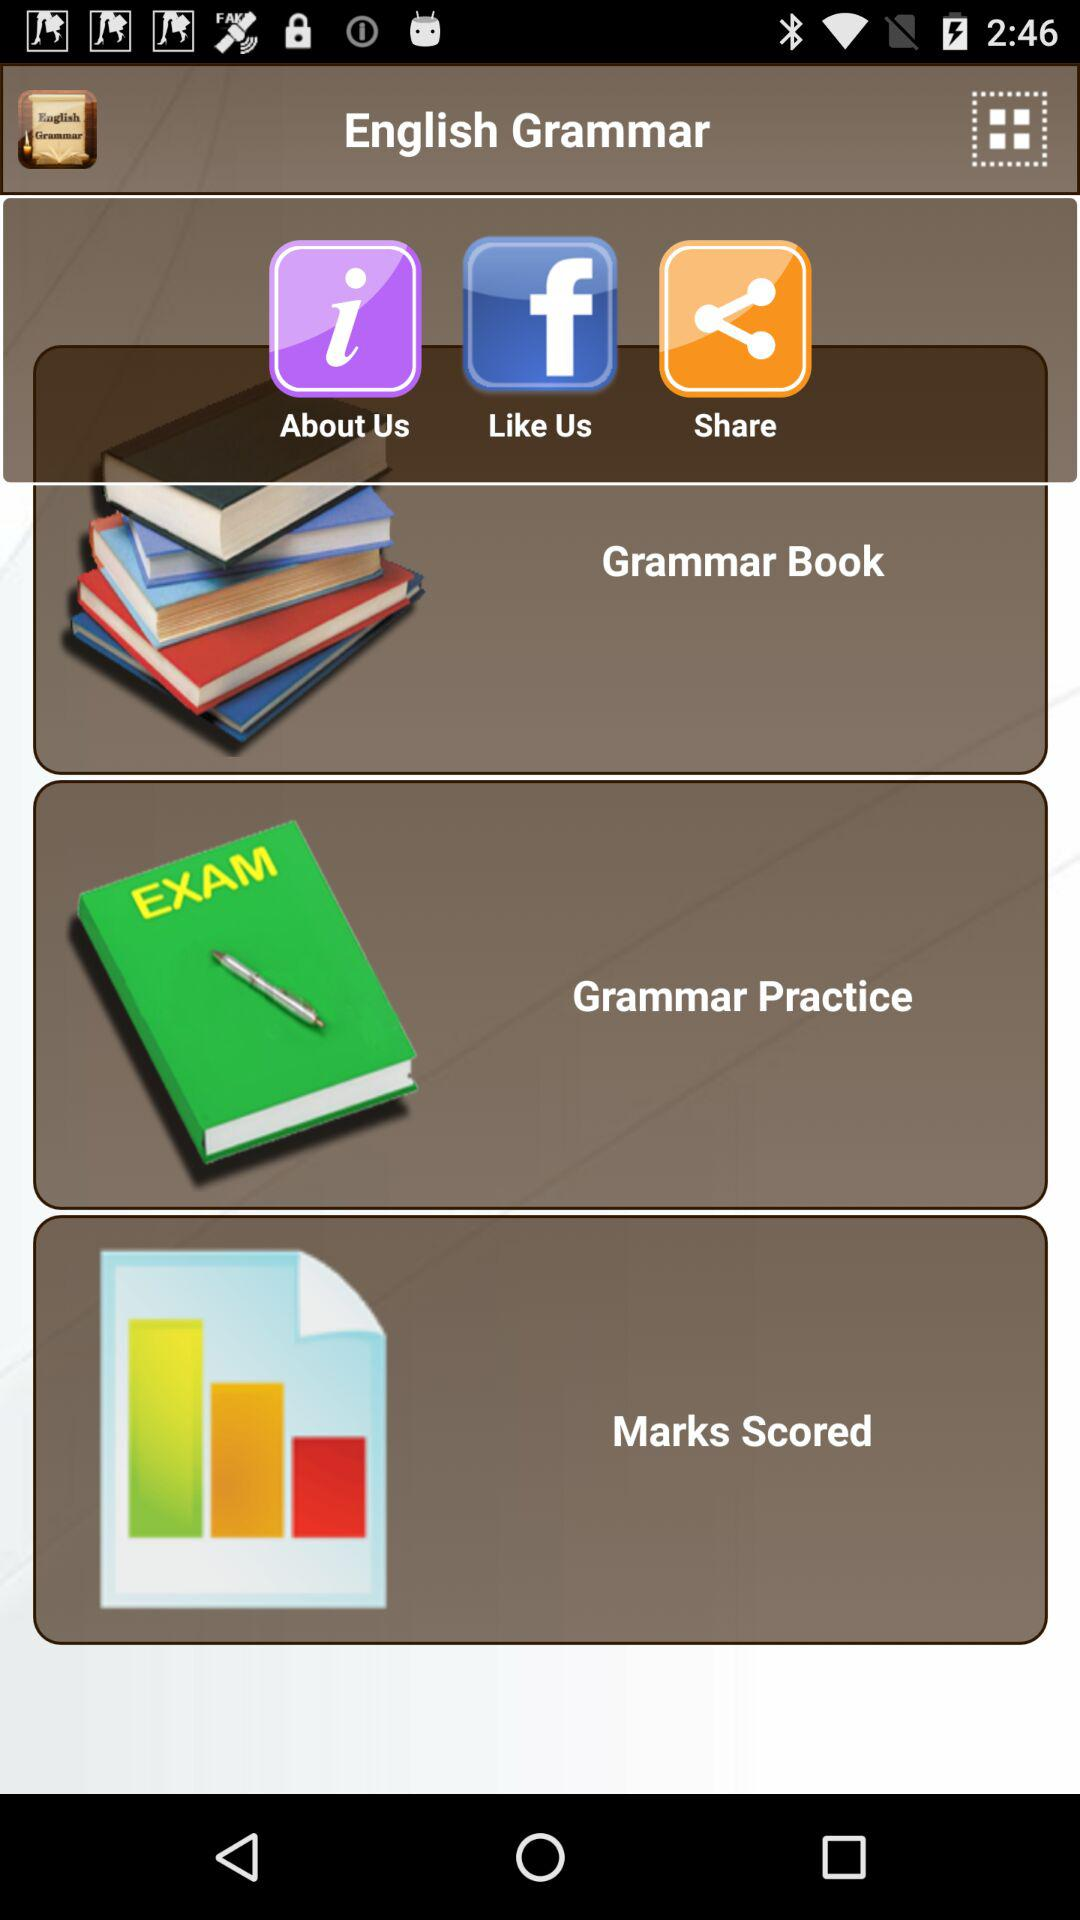What is the name of the application? The application name is "English Grammar". 